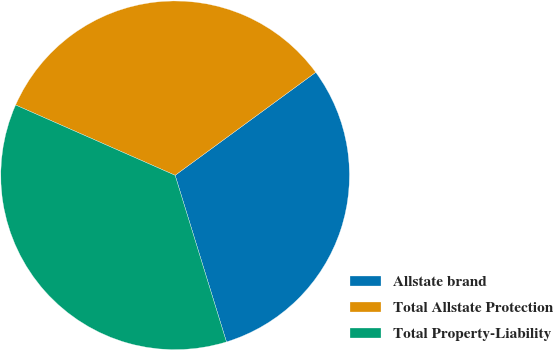Convert chart. <chart><loc_0><loc_0><loc_500><loc_500><pie_chart><fcel>Allstate brand<fcel>Total Allstate Protection<fcel>Total Property-Liability<nl><fcel>30.3%<fcel>33.33%<fcel>36.36%<nl></chart> 